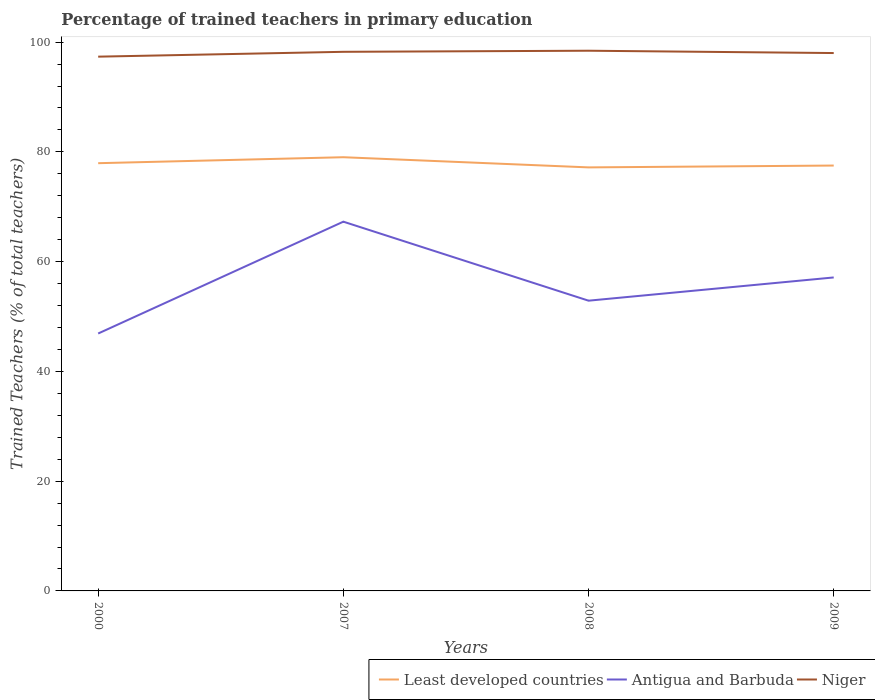How many different coloured lines are there?
Keep it short and to the point. 3. Does the line corresponding to Least developed countries intersect with the line corresponding to Antigua and Barbuda?
Make the answer very short. No. Across all years, what is the maximum percentage of trained teachers in Least developed countries?
Make the answer very short. 77.18. In which year was the percentage of trained teachers in Least developed countries maximum?
Keep it short and to the point. 2008. What is the total percentage of trained teachers in Antigua and Barbuda in the graph?
Keep it short and to the point. -10.22. What is the difference between the highest and the second highest percentage of trained teachers in Niger?
Provide a succinct answer. 1.08. What is the difference between the highest and the lowest percentage of trained teachers in Antigua and Barbuda?
Offer a terse response. 2. How many lines are there?
Give a very brief answer. 3. How many years are there in the graph?
Your answer should be very brief. 4. Are the values on the major ticks of Y-axis written in scientific E-notation?
Provide a short and direct response. No. Does the graph contain any zero values?
Ensure brevity in your answer.  No. How many legend labels are there?
Offer a very short reply. 3. What is the title of the graph?
Offer a terse response. Percentage of trained teachers in primary education. What is the label or title of the X-axis?
Your answer should be compact. Years. What is the label or title of the Y-axis?
Keep it short and to the point. Trained Teachers (% of total teachers). What is the Trained Teachers (% of total teachers) of Least developed countries in 2000?
Your answer should be compact. 77.94. What is the Trained Teachers (% of total teachers) of Antigua and Barbuda in 2000?
Your answer should be very brief. 46.91. What is the Trained Teachers (% of total teachers) of Niger in 2000?
Offer a terse response. 97.35. What is the Trained Teachers (% of total teachers) in Least developed countries in 2007?
Your response must be concise. 79.03. What is the Trained Teachers (% of total teachers) in Antigua and Barbuda in 2007?
Offer a terse response. 67.29. What is the Trained Teachers (% of total teachers) of Niger in 2007?
Keep it short and to the point. 98.24. What is the Trained Teachers (% of total teachers) of Least developed countries in 2008?
Provide a short and direct response. 77.18. What is the Trained Teachers (% of total teachers) in Antigua and Barbuda in 2008?
Offer a terse response. 52.89. What is the Trained Teachers (% of total teachers) in Niger in 2008?
Provide a succinct answer. 98.44. What is the Trained Teachers (% of total teachers) in Least developed countries in 2009?
Provide a succinct answer. 77.51. What is the Trained Teachers (% of total teachers) of Antigua and Barbuda in 2009?
Make the answer very short. 57.12. What is the Trained Teachers (% of total teachers) of Niger in 2009?
Provide a short and direct response. 98.01. Across all years, what is the maximum Trained Teachers (% of total teachers) in Least developed countries?
Offer a very short reply. 79.03. Across all years, what is the maximum Trained Teachers (% of total teachers) of Antigua and Barbuda?
Make the answer very short. 67.29. Across all years, what is the maximum Trained Teachers (% of total teachers) in Niger?
Your response must be concise. 98.44. Across all years, what is the minimum Trained Teachers (% of total teachers) in Least developed countries?
Offer a very short reply. 77.18. Across all years, what is the minimum Trained Teachers (% of total teachers) of Antigua and Barbuda?
Offer a very short reply. 46.91. Across all years, what is the minimum Trained Teachers (% of total teachers) of Niger?
Offer a terse response. 97.35. What is the total Trained Teachers (% of total teachers) of Least developed countries in the graph?
Your answer should be compact. 311.66. What is the total Trained Teachers (% of total teachers) in Antigua and Barbuda in the graph?
Offer a very short reply. 224.2. What is the total Trained Teachers (% of total teachers) in Niger in the graph?
Ensure brevity in your answer.  392.04. What is the difference between the Trained Teachers (% of total teachers) of Least developed countries in 2000 and that in 2007?
Ensure brevity in your answer.  -1.09. What is the difference between the Trained Teachers (% of total teachers) of Antigua and Barbuda in 2000 and that in 2007?
Keep it short and to the point. -20.38. What is the difference between the Trained Teachers (% of total teachers) of Niger in 2000 and that in 2007?
Offer a terse response. -0.88. What is the difference between the Trained Teachers (% of total teachers) in Least developed countries in 2000 and that in 2008?
Provide a short and direct response. 0.77. What is the difference between the Trained Teachers (% of total teachers) in Antigua and Barbuda in 2000 and that in 2008?
Ensure brevity in your answer.  -5.98. What is the difference between the Trained Teachers (% of total teachers) in Niger in 2000 and that in 2008?
Offer a very short reply. -1.08. What is the difference between the Trained Teachers (% of total teachers) of Least developed countries in 2000 and that in 2009?
Give a very brief answer. 0.43. What is the difference between the Trained Teachers (% of total teachers) of Antigua and Barbuda in 2000 and that in 2009?
Ensure brevity in your answer.  -10.22. What is the difference between the Trained Teachers (% of total teachers) of Niger in 2000 and that in 2009?
Ensure brevity in your answer.  -0.66. What is the difference between the Trained Teachers (% of total teachers) in Least developed countries in 2007 and that in 2008?
Make the answer very short. 1.85. What is the difference between the Trained Teachers (% of total teachers) in Antigua and Barbuda in 2007 and that in 2008?
Provide a succinct answer. 14.4. What is the difference between the Trained Teachers (% of total teachers) of Niger in 2007 and that in 2008?
Provide a short and direct response. -0.2. What is the difference between the Trained Teachers (% of total teachers) in Least developed countries in 2007 and that in 2009?
Keep it short and to the point. 1.52. What is the difference between the Trained Teachers (% of total teachers) in Antigua and Barbuda in 2007 and that in 2009?
Ensure brevity in your answer.  10.16. What is the difference between the Trained Teachers (% of total teachers) in Niger in 2007 and that in 2009?
Give a very brief answer. 0.22. What is the difference between the Trained Teachers (% of total teachers) in Least developed countries in 2008 and that in 2009?
Your response must be concise. -0.34. What is the difference between the Trained Teachers (% of total teachers) in Antigua and Barbuda in 2008 and that in 2009?
Your answer should be very brief. -4.23. What is the difference between the Trained Teachers (% of total teachers) of Niger in 2008 and that in 2009?
Provide a short and direct response. 0.42. What is the difference between the Trained Teachers (% of total teachers) of Least developed countries in 2000 and the Trained Teachers (% of total teachers) of Antigua and Barbuda in 2007?
Your answer should be very brief. 10.66. What is the difference between the Trained Teachers (% of total teachers) of Least developed countries in 2000 and the Trained Teachers (% of total teachers) of Niger in 2007?
Offer a terse response. -20.29. What is the difference between the Trained Teachers (% of total teachers) in Antigua and Barbuda in 2000 and the Trained Teachers (% of total teachers) in Niger in 2007?
Provide a succinct answer. -51.33. What is the difference between the Trained Teachers (% of total teachers) in Least developed countries in 2000 and the Trained Teachers (% of total teachers) in Antigua and Barbuda in 2008?
Provide a short and direct response. 25.05. What is the difference between the Trained Teachers (% of total teachers) in Least developed countries in 2000 and the Trained Teachers (% of total teachers) in Niger in 2008?
Make the answer very short. -20.49. What is the difference between the Trained Teachers (% of total teachers) of Antigua and Barbuda in 2000 and the Trained Teachers (% of total teachers) of Niger in 2008?
Offer a terse response. -51.53. What is the difference between the Trained Teachers (% of total teachers) in Least developed countries in 2000 and the Trained Teachers (% of total teachers) in Antigua and Barbuda in 2009?
Provide a short and direct response. 20.82. What is the difference between the Trained Teachers (% of total teachers) in Least developed countries in 2000 and the Trained Teachers (% of total teachers) in Niger in 2009?
Offer a terse response. -20.07. What is the difference between the Trained Teachers (% of total teachers) in Antigua and Barbuda in 2000 and the Trained Teachers (% of total teachers) in Niger in 2009?
Keep it short and to the point. -51.11. What is the difference between the Trained Teachers (% of total teachers) of Least developed countries in 2007 and the Trained Teachers (% of total teachers) of Antigua and Barbuda in 2008?
Your response must be concise. 26.14. What is the difference between the Trained Teachers (% of total teachers) in Least developed countries in 2007 and the Trained Teachers (% of total teachers) in Niger in 2008?
Your answer should be compact. -19.41. What is the difference between the Trained Teachers (% of total teachers) in Antigua and Barbuda in 2007 and the Trained Teachers (% of total teachers) in Niger in 2008?
Your answer should be very brief. -31.15. What is the difference between the Trained Teachers (% of total teachers) of Least developed countries in 2007 and the Trained Teachers (% of total teachers) of Antigua and Barbuda in 2009?
Your answer should be compact. 21.91. What is the difference between the Trained Teachers (% of total teachers) of Least developed countries in 2007 and the Trained Teachers (% of total teachers) of Niger in 2009?
Offer a very short reply. -18.98. What is the difference between the Trained Teachers (% of total teachers) of Antigua and Barbuda in 2007 and the Trained Teachers (% of total teachers) of Niger in 2009?
Keep it short and to the point. -30.73. What is the difference between the Trained Teachers (% of total teachers) in Least developed countries in 2008 and the Trained Teachers (% of total teachers) in Antigua and Barbuda in 2009?
Give a very brief answer. 20.05. What is the difference between the Trained Teachers (% of total teachers) of Least developed countries in 2008 and the Trained Teachers (% of total teachers) of Niger in 2009?
Provide a succinct answer. -20.84. What is the difference between the Trained Teachers (% of total teachers) of Antigua and Barbuda in 2008 and the Trained Teachers (% of total teachers) of Niger in 2009?
Your answer should be compact. -45.12. What is the average Trained Teachers (% of total teachers) in Least developed countries per year?
Provide a succinct answer. 77.92. What is the average Trained Teachers (% of total teachers) in Antigua and Barbuda per year?
Give a very brief answer. 56.05. What is the average Trained Teachers (% of total teachers) in Niger per year?
Provide a succinct answer. 98.01. In the year 2000, what is the difference between the Trained Teachers (% of total teachers) of Least developed countries and Trained Teachers (% of total teachers) of Antigua and Barbuda?
Your answer should be very brief. 31.04. In the year 2000, what is the difference between the Trained Teachers (% of total teachers) of Least developed countries and Trained Teachers (% of total teachers) of Niger?
Your answer should be very brief. -19.41. In the year 2000, what is the difference between the Trained Teachers (% of total teachers) of Antigua and Barbuda and Trained Teachers (% of total teachers) of Niger?
Provide a succinct answer. -50.45. In the year 2007, what is the difference between the Trained Teachers (% of total teachers) in Least developed countries and Trained Teachers (% of total teachers) in Antigua and Barbuda?
Offer a terse response. 11.74. In the year 2007, what is the difference between the Trained Teachers (% of total teachers) in Least developed countries and Trained Teachers (% of total teachers) in Niger?
Your answer should be compact. -19.21. In the year 2007, what is the difference between the Trained Teachers (% of total teachers) of Antigua and Barbuda and Trained Teachers (% of total teachers) of Niger?
Your response must be concise. -30.95. In the year 2008, what is the difference between the Trained Teachers (% of total teachers) of Least developed countries and Trained Teachers (% of total teachers) of Antigua and Barbuda?
Keep it short and to the point. 24.29. In the year 2008, what is the difference between the Trained Teachers (% of total teachers) in Least developed countries and Trained Teachers (% of total teachers) in Niger?
Your response must be concise. -21.26. In the year 2008, what is the difference between the Trained Teachers (% of total teachers) in Antigua and Barbuda and Trained Teachers (% of total teachers) in Niger?
Provide a short and direct response. -45.55. In the year 2009, what is the difference between the Trained Teachers (% of total teachers) in Least developed countries and Trained Teachers (% of total teachers) in Antigua and Barbuda?
Provide a short and direct response. 20.39. In the year 2009, what is the difference between the Trained Teachers (% of total teachers) in Least developed countries and Trained Teachers (% of total teachers) in Niger?
Make the answer very short. -20.5. In the year 2009, what is the difference between the Trained Teachers (% of total teachers) in Antigua and Barbuda and Trained Teachers (% of total teachers) in Niger?
Your response must be concise. -40.89. What is the ratio of the Trained Teachers (% of total teachers) of Least developed countries in 2000 to that in 2007?
Provide a succinct answer. 0.99. What is the ratio of the Trained Teachers (% of total teachers) of Antigua and Barbuda in 2000 to that in 2007?
Ensure brevity in your answer.  0.7. What is the ratio of the Trained Teachers (% of total teachers) of Least developed countries in 2000 to that in 2008?
Provide a succinct answer. 1.01. What is the ratio of the Trained Teachers (% of total teachers) of Antigua and Barbuda in 2000 to that in 2008?
Ensure brevity in your answer.  0.89. What is the ratio of the Trained Teachers (% of total teachers) in Niger in 2000 to that in 2008?
Provide a succinct answer. 0.99. What is the ratio of the Trained Teachers (% of total teachers) in Least developed countries in 2000 to that in 2009?
Provide a short and direct response. 1.01. What is the ratio of the Trained Teachers (% of total teachers) in Antigua and Barbuda in 2000 to that in 2009?
Provide a short and direct response. 0.82. What is the ratio of the Trained Teachers (% of total teachers) of Antigua and Barbuda in 2007 to that in 2008?
Make the answer very short. 1.27. What is the ratio of the Trained Teachers (% of total teachers) in Niger in 2007 to that in 2008?
Provide a succinct answer. 1. What is the ratio of the Trained Teachers (% of total teachers) of Least developed countries in 2007 to that in 2009?
Your answer should be very brief. 1.02. What is the ratio of the Trained Teachers (% of total teachers) in Antigua and Barbuda in 2007 to that in 2009?
Your answer should be compact. 1.18. What is the ratio of the Trained Teachers (% of total teachers) in Niger in 2007 to that in 2009?
Offer a terse response. 1. What is the ratio of the Trained Teachers (% of total teachers) of Least developed countries in 2008 to that in 2009?
Make the answer very short. 1. What is the ratio of the Trained Teachers (% of total teachers) in Antigua and Barbuda in 2008 to that in 2009?
Give a very brief answer. 0.93. What is the ratio of the Trained Teachers (% of total teachers) in Niger in 2008 to that in 2009?
Your answer should be compact. 1. What is the difference between the highest and the second highest Trained Teachers (% of total teachers) in Least developed countries?
Ensure brevity in your answer.  1.09. What is the difference between the highest and the second highest Trained Teachers (% of total teachers) of Antigua and Barbuda?
Offer a very short reply. 10.16. What is the difference between the highest and the second highest Trained Teachers (% of total teachers) of Niger?
Your response must be concise. 0.2. What is the difference between the highest and the lowest Trained Teachers (% of total teachers) in Least developed countries?
Ensure brevity in your answer.  1.85. What is the difference between the highest and the lowest Trained Teachers (% of total teachers) of Antigua and Barbuda?
Your answer should be compact. 20.38. What is the difference between the highest and the lowest Trained Teachers (% of total teachers) in Niger?
Provide a short and direct response. 1.08. 